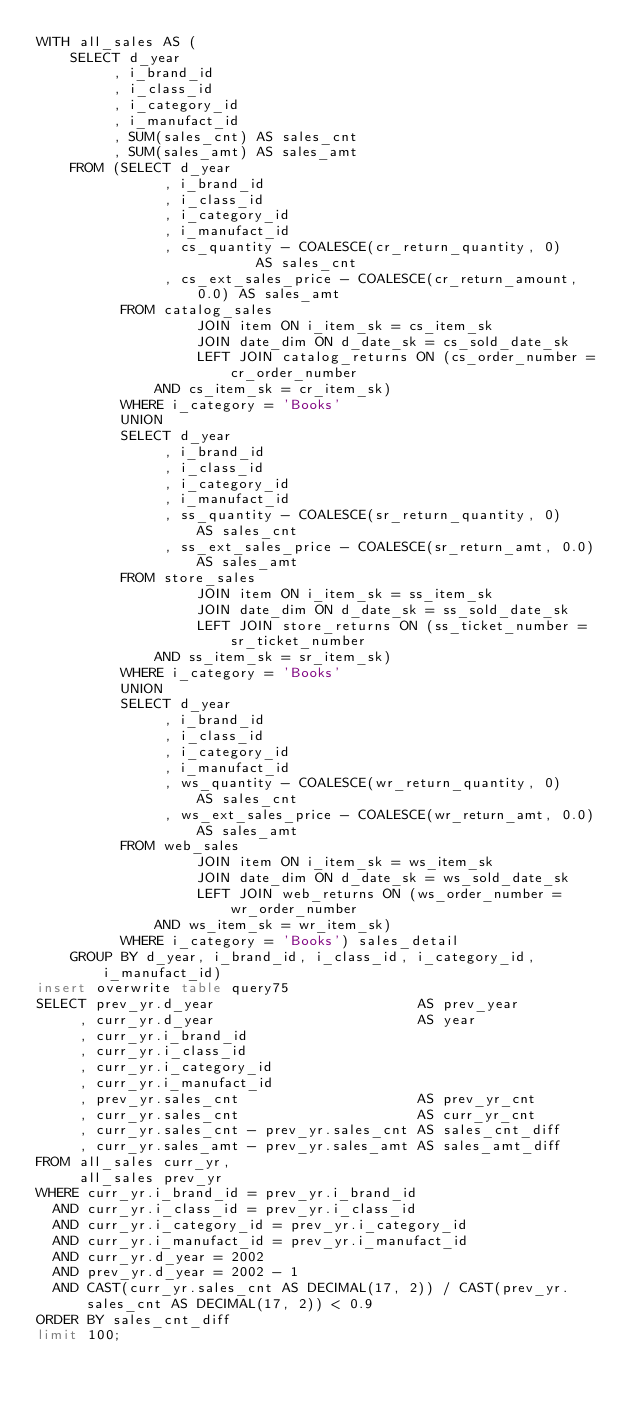<code> <loc_0><loc_0><loc_500><loc_500><_SQL_>WITH all_sales AS (
    SELECT d_year
         , i_brand_id
         , i_class_id
         , i_category_id
         , i_manufact_id
         , SUM(sales_cnt) AS sales_cnt
         , SUM(sales_amt) AS sales_amt
    FROM (SELECT d_year
               , i_brand_id
               , i_class_id
               , i_category_id
               , i_manufact_id
               , cs_quantity - COALESCE(cr_return_quantity, 0)        AS sales_cnt
               , cs_ext_sales_price - COALESCE(cr_return_amount, 0.0) AS sales_amt
          FROM catalog_sales
                   JOIN item ON i_item_sk = cs_item_sk
                   JOIN date_dim ON d_date_sk = cs_sold_date_sk
                   LEFT JOIN catalog_returns ON (cs_order_number = cr_order_number
              AND cs_item_sk = cr_item_sk)
          WHERE i_category = 'Books'
          UNION
          SELECT d_year
               , i_brand_id
               , i_class_id
               , i_category_id
               , i_manufact_id
               , ss_quantity - COALESCE(sr_return_quantity, 0)     AS sales_cnt
               , ss_ext_sales_price - COALESCE(sr_return_amt, 0.0) AS sales_amt
          FROM store_sales
                   JOIN item ON i_item_sk = ss_item_sk
                   JOIN date_dim ON d_date_sk = ss_sold_date_sk
                   LEFT JOIN store_returns ON (ss_ticket_number = sr_ticket_number
              AND ss_item_sk = sr_item_sk)
          WHERE i_category = 'Books'
          UNION
          SELECT d_year
               , i_brand_id
               , i_class_id
               , i_category_id
               , i_manufact_id
               , ws_quantity - COALESCE(wr_return_quantity, 0)     AS sales_cnt
               , ws_ext_sales_price - COALESCE(wr_return_amt, 0.0) AS sales_amt
          FROM web_sales
                   JOIN item ON i_item_sk = ws_item_sk
                   JOIN date_dim ON d_date_sk = ws_sold_date_sk
                   LEFT JOIN web_returns ON (ws_order_number = wr_order_number
              AND ws_item_sk = wr_item_sk)
          WHERE i_category = 'Books') sales_detail
    GROUP BY d_year, i_brand_id, i_class_id, i_category_id, i_manufact_id)
insert overwrite table query75
SELECT prev_yr.d_year                        AS prev_year
     , curr_yr.d_year                        AS year
     , curr_yr.i_brand_id
     , curr_yr.i_class_id
     , curr_yr.i_category_id
     , curr_yr.i_manufact_id
     , prev_yr.sales_cnt                     AS prev_yr_cnt
     , curr_yr.sales_cnt                     AS curr_yr_cnt
     , curr_yr.sales_cnt - prev_yr.sales_cnt AS sales_cnt_diff
     , curr_yr.sales_amt - prev_yr.sales_amt AS sales_amt_diff
FROM all_sales curr_yr,
     all_sales prev_yr
WHERE curr_yr.i_brand_id = prev_yr.i_brand_id
  AND curr_yr.i_class_id = prev_yr.i_class_id
  AND curr_yr.i_category_id = prev_yr.i_category_id
  AND curr_yr.i_manufact_id = prev_yr.i_manufact_id
  AND curr_yr.d_year = 2002
  AND prev_yr.d_year = 2002 - 1
  AND CAST(curr_yr.sales_cnt AS DECIMAL(17, 2)) / CAST(prev_yr.sales_cnt AS DECIMAL(17, 2)) < 0.9
ORDER BY sales_cnt_diff
limit 100;
</code> 